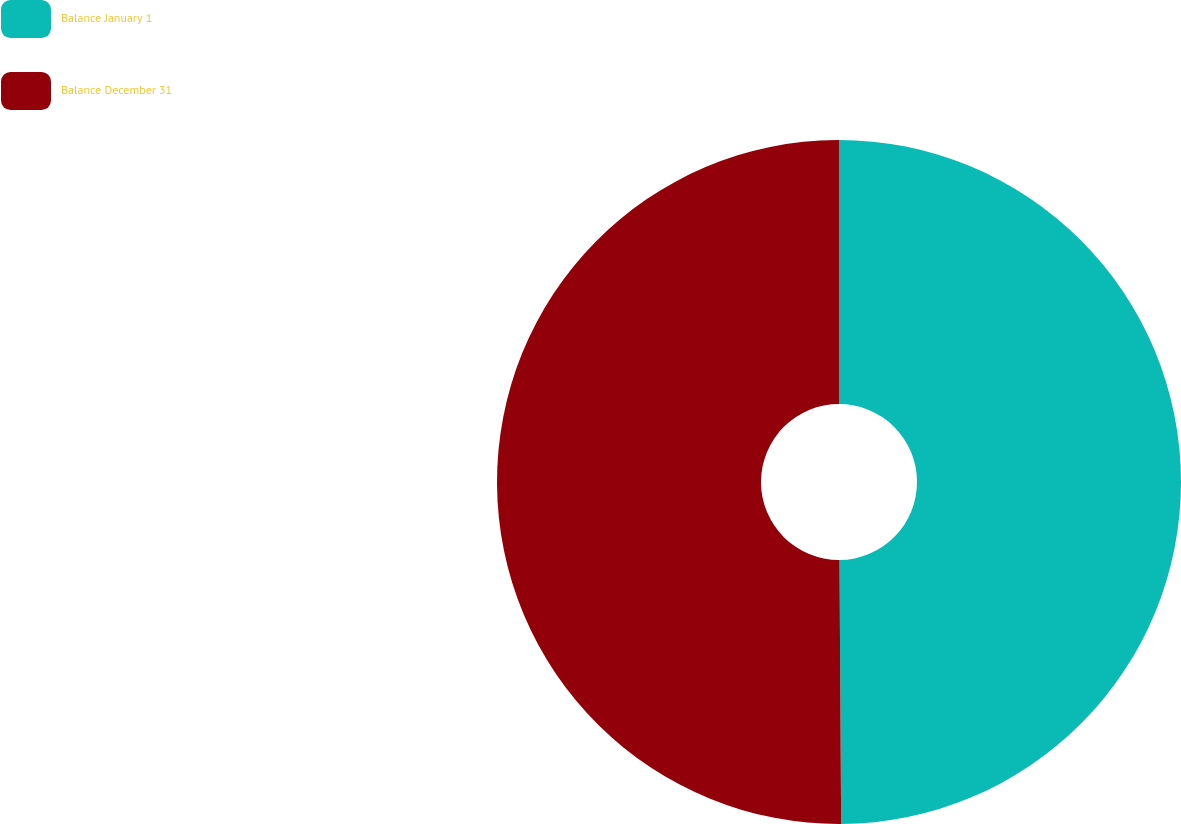Convert chart to OTSL. <chart><loc_0><loc_0><loc_500><loc_500><pie_chart><fcel>Balance January 1<fcel>Balance December 31<nl><fcel>49.9%<fcel>50.1%<nl></chart> 